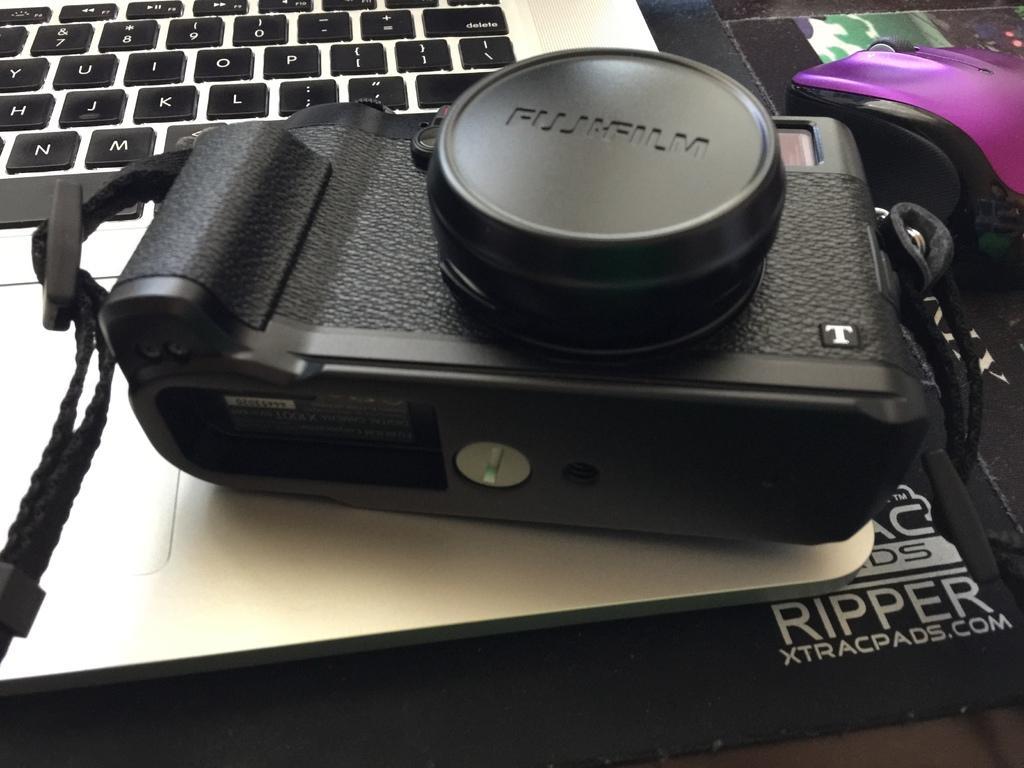In one or two sentences, can you explain what this image depicts? In the picture there is a camera present on the laptop, beside the laptop there is a mouse present. 